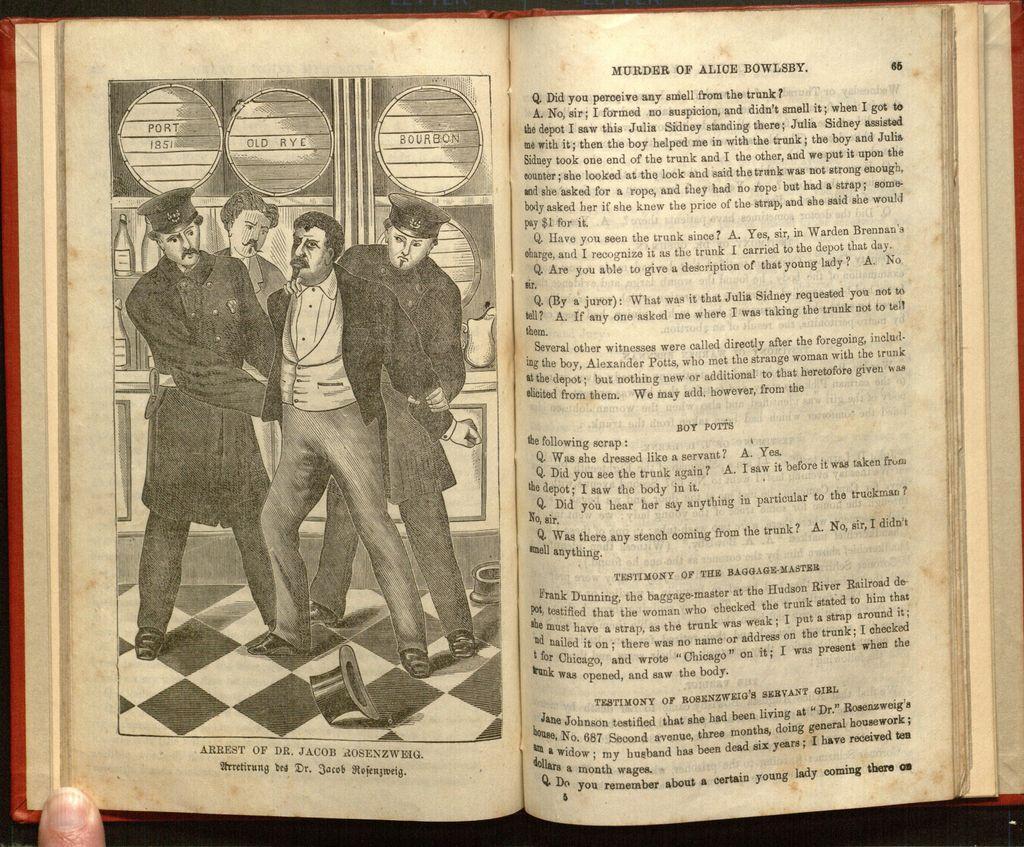Describe this image in one or two sentences. This is an open book. In this picture we can see two people holding a person. We can see another person at the back. There is some text visible on top and at the bottom of the picture on the left side. We can see some text on the right side. There is a finger visible on a book in the bottom left. 